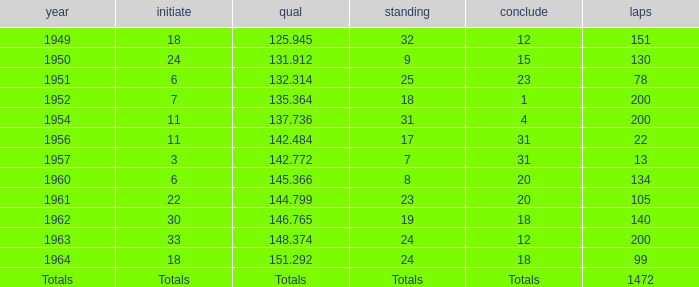Name the rank for 151 Laps 32.0. 